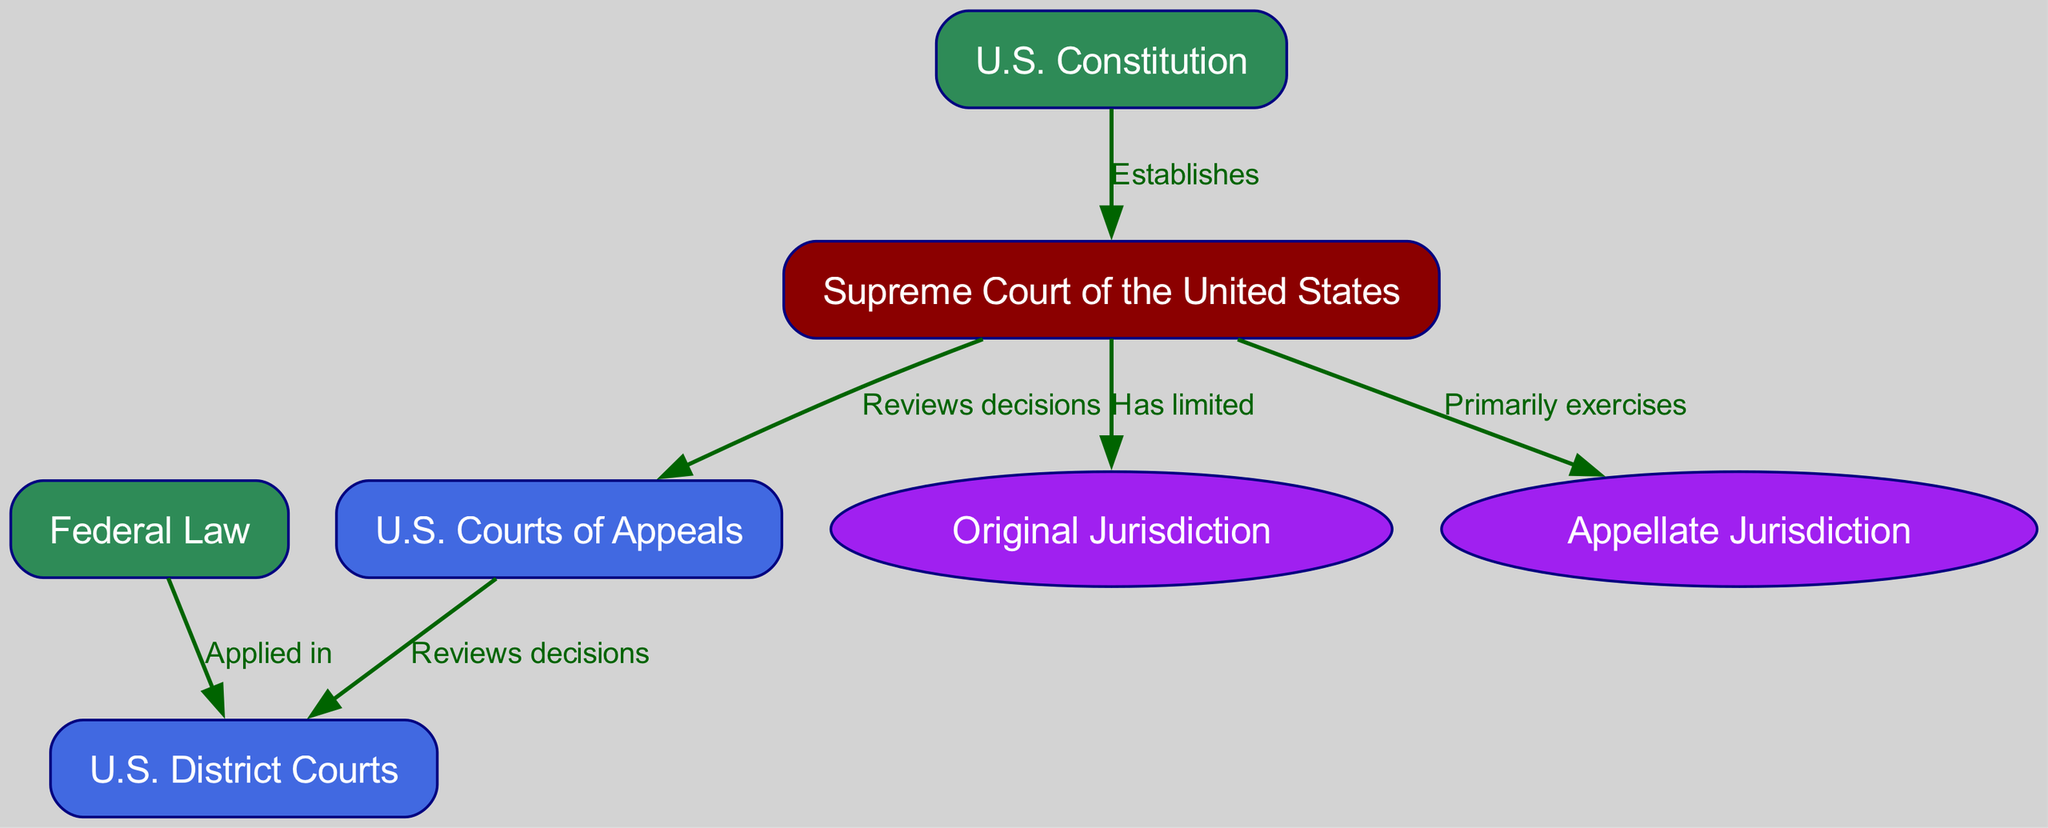What are the two main types of jurisdiction exercised by the Supreme Court? The diagram states that the Supreme Court primarily exercises appellate jurisdiction and has limited original jurisdiction. Both of these terms are connected as nodes indicating the types of jurisdiction in the context of the Supreme Court.
Answer: Appellate jurisdiction and original jurisdiction How many types of courts are represented in the diagram? The diagram includes three main types of courts: the Supreme Court of the United States, U.S. Courts of Appeals, and U.S. District Courts. Each of these is a distinct node that represents a type of court in the federal court system.
Answer: Three Which court reviews decisions from the U.S. District Courts? According to the diagram, the U.S. Courts of Appeals reviews decisions from the U.S. District Courts, which is indicated by a directed edge leading from the courts of appeals to the district courts.
Answer: U.S. Courts of Appeals What document establishes the Supreme Court? The diagram shows that the Supreme Court of the United States is established by the U.S. Constitution, as indicated by a directed edge labeled "Establishes" connecting these two nodes.
Answer: U.S. Constitution What type of law is applied in U.S. District Courts? The diagram indicates that Federal Law is applied in U.S. District Courts. This relationship is shown with a directed edge pointing from the federal law node to the district courts node.
Answer: Federal Law What role does the Supreme Court have in relation to the U.S. Courts of Appeals? The Supreme Court reviews decisions made by the U.S. Courts of Appeals, as illustrated by a directed edge connecting the two and labeled "Reviews decisions." This indicates the oversight and reviewing function of the Supreme Court.
Answer: Reviews decisions Which jurisdiction does the Supreme Court primarily exercise? The diagram indicates that the Supreme Court primarily exercises appellate jurisdiction, as this is shown connecting to the Supreme Court node with the label "Primarily exercises." This defines its main role in the federal court system.
Answer: Appellate jurisdiction Which court applies federal law according to the diagram? The U.S. District Courts apply federal law, as indicated by a directed edge stating "Applied in" from the federal law node to the district courts node. This shows the function of the district courts in relation to the legal framework.
Answer: U.S. District Courts 